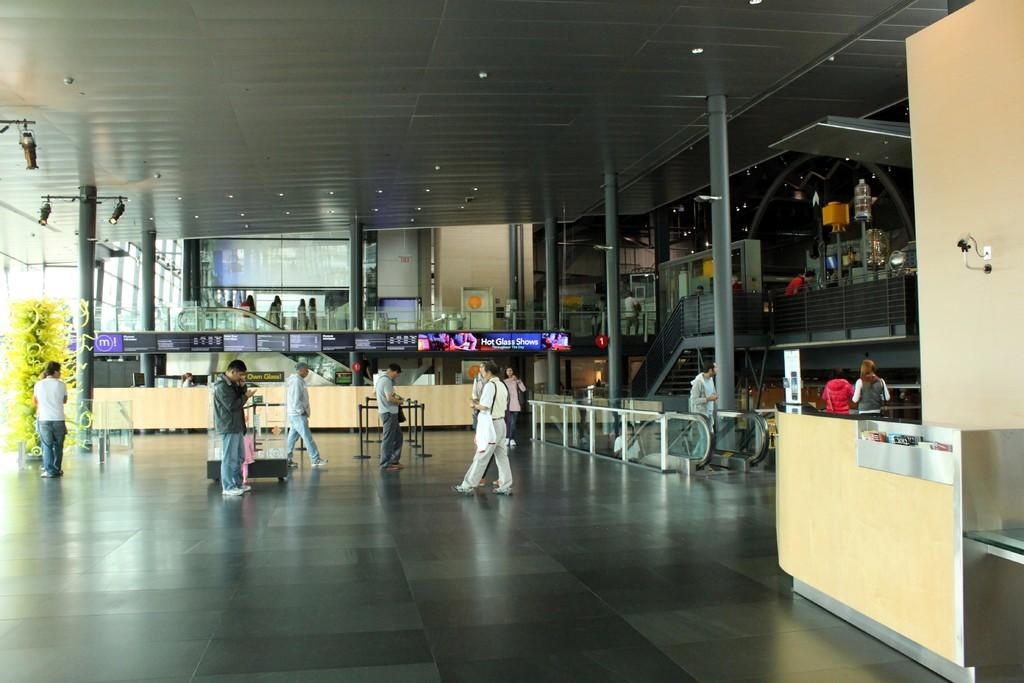How many people are in the image? There are many people in the image. What are some of the people doing in the image? Some people are standing, while others are walking. What are the people wearing in the image? The people are wearing clothes and shoes. Can you describe the setting of the image? There is a floor, a wall, a fence, a pole, and lights visible in the image. Is there any vegetation present in the image? Yes, there is a plant in the image. What type of chairs can be seen in the image? There are no chairs present in the image. What degree of fog is visible in the image? There is no fog present in the image. 